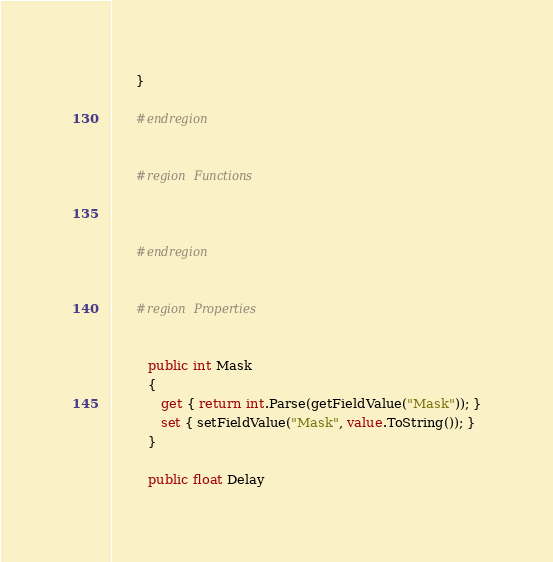<code> <loc_0><loc_0><loc_500><loc_500><_C#_>      }
      
      #endregion


      #region Functions
      
      
      
      #endregion


      #region Properties
      
      
         public int Mask
         {
         	get { return int.Parse(getFieldValue("Mask")); }
         	set { setFieldValue("Mask", value.ToString()); }
         }
      
         public float Delay</code> 